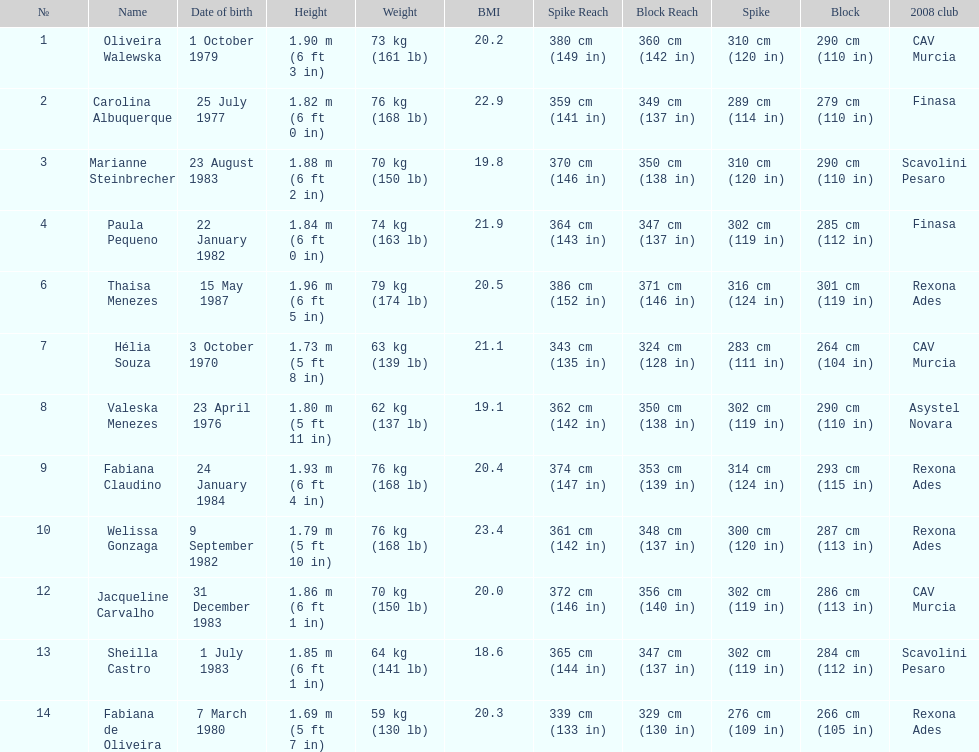Whose weight is the heaviest among the following: fabiana de oliveira, helia souza, or sheilla castro? Sheilla Castro. 